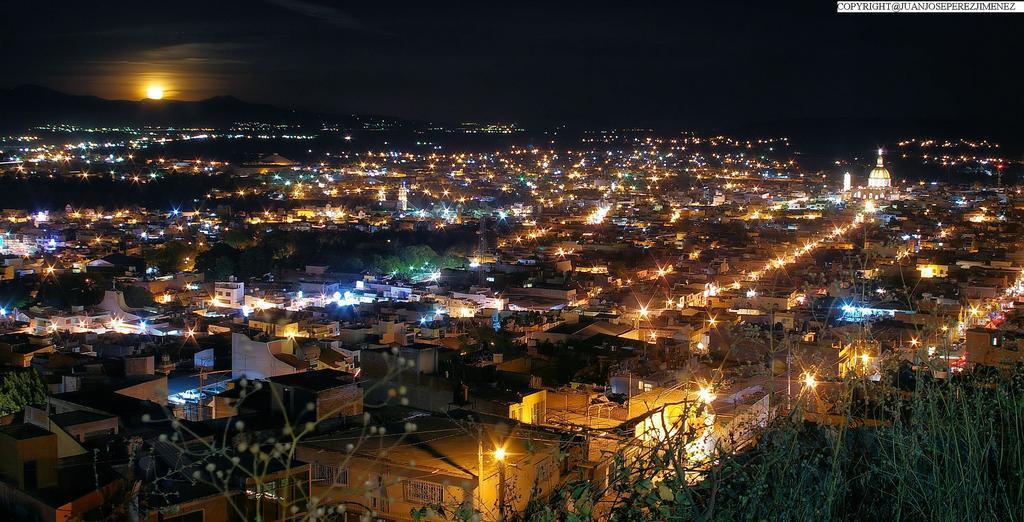Can you describe this image briefly? In this image, I can see the view of a city with the buildings, lights and trees. At the bottom of the image, I can see the plants. In the background, there are hills and the sun in the sky. 